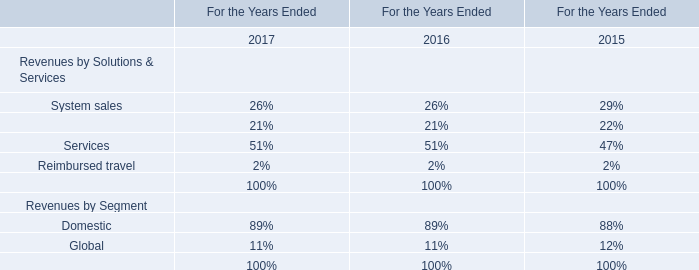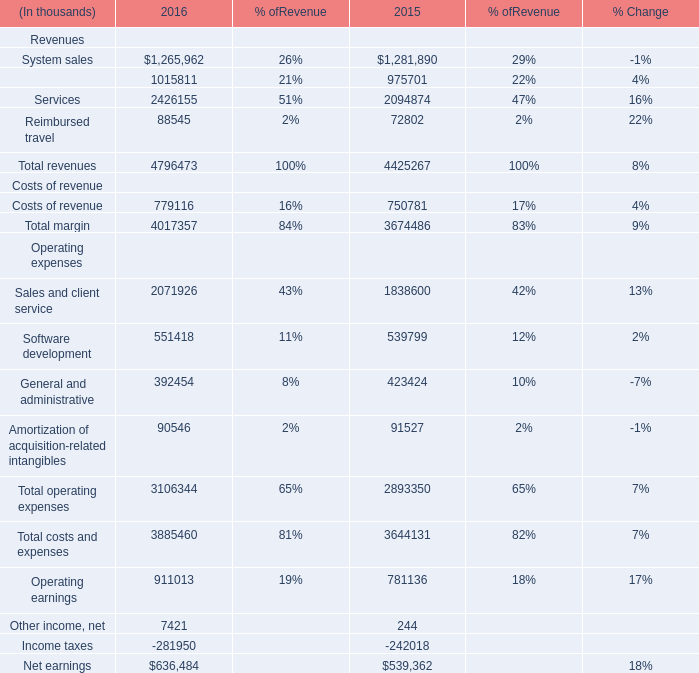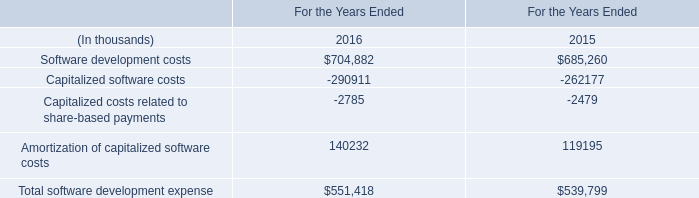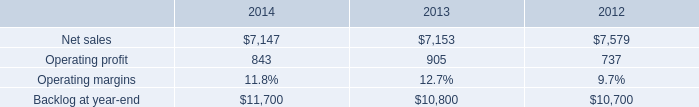What is the ratioof System sales Revenues to the total in 2016? 
Computations: (1265962 / 4796473)
Answer: 0.26394. 